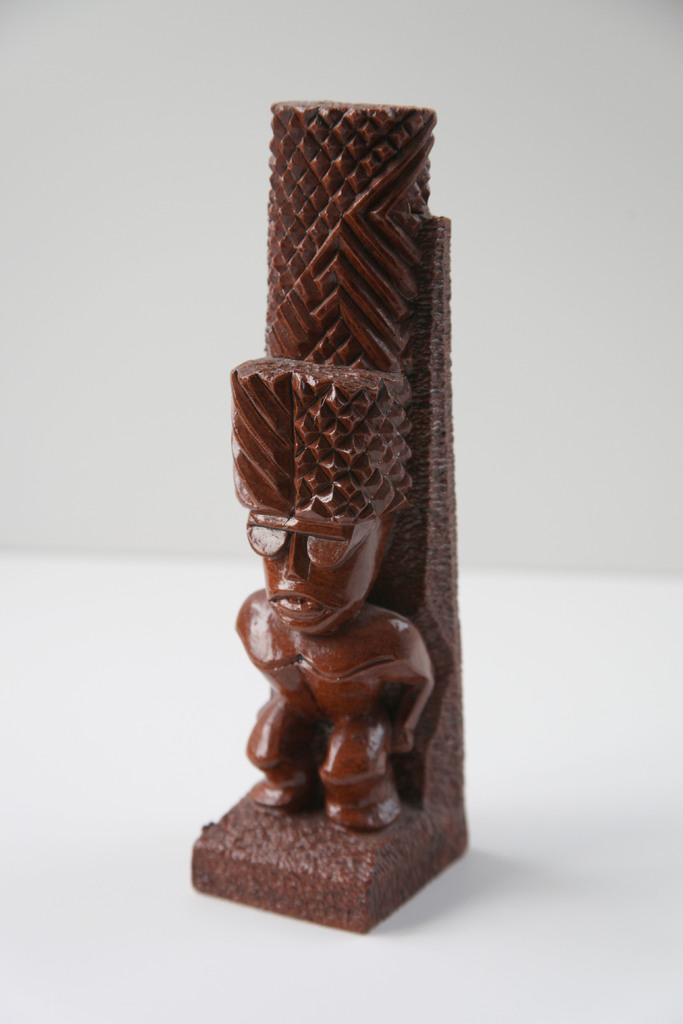What is the main subject in the middle of the image? There is a sculpture in the middle of the image. Where is the sculpture located? The sculpture is on the floor. What can be seen in the background of the image? There is an off-white wall in the background of the image. What type of setting is suggested by the image? The image is likely taken in a room. How many questions are visible in the image? There are no questions present in the image; it features a sculpture on the floor with an off-white wall in the background. 